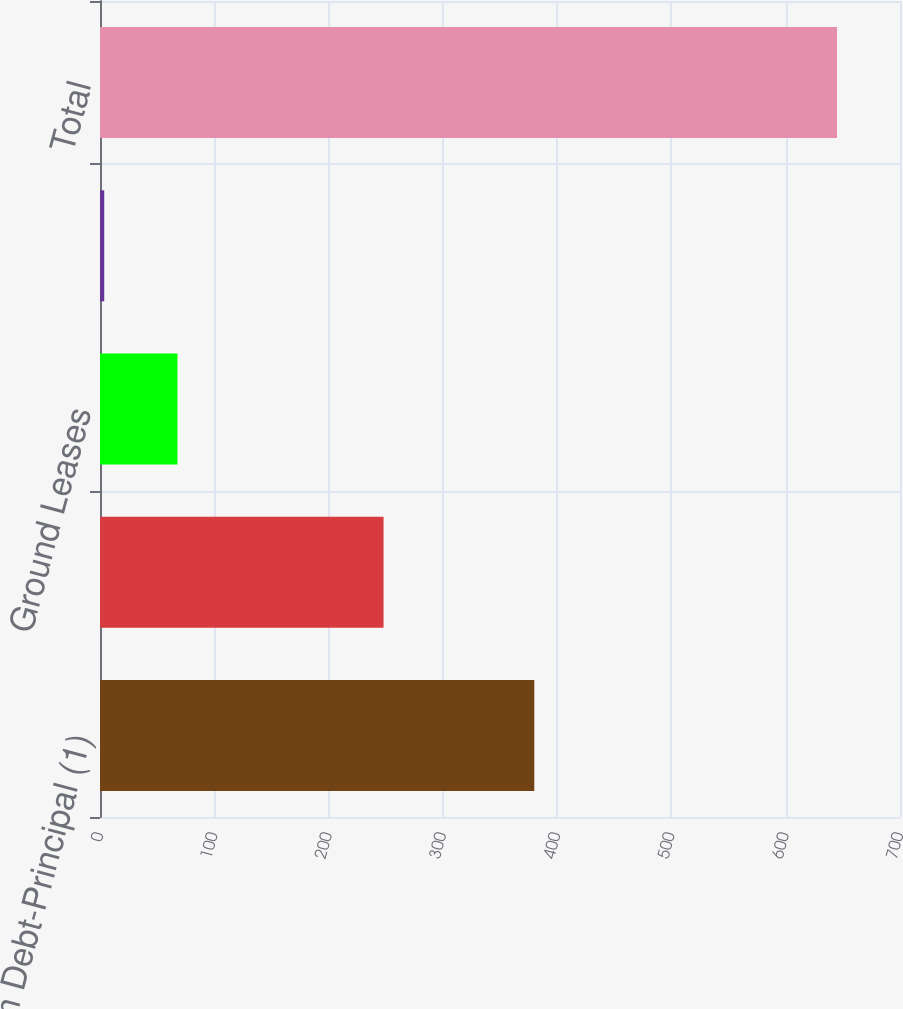Convert chart. <chart><loc_0><loc_0><loc_500><loc_500><bar_chart><fcel>Long-Term Debt-Principal (1)<fcel>Long-Term Debt-Interest (2)<fcel>Ground Leases<fcel>Retail Store Leases<fcel>Total<nl><fcel>380<fcel>248.1<fcel>67.82<fcel>3.7<fcel>644.9<nl></chart> 